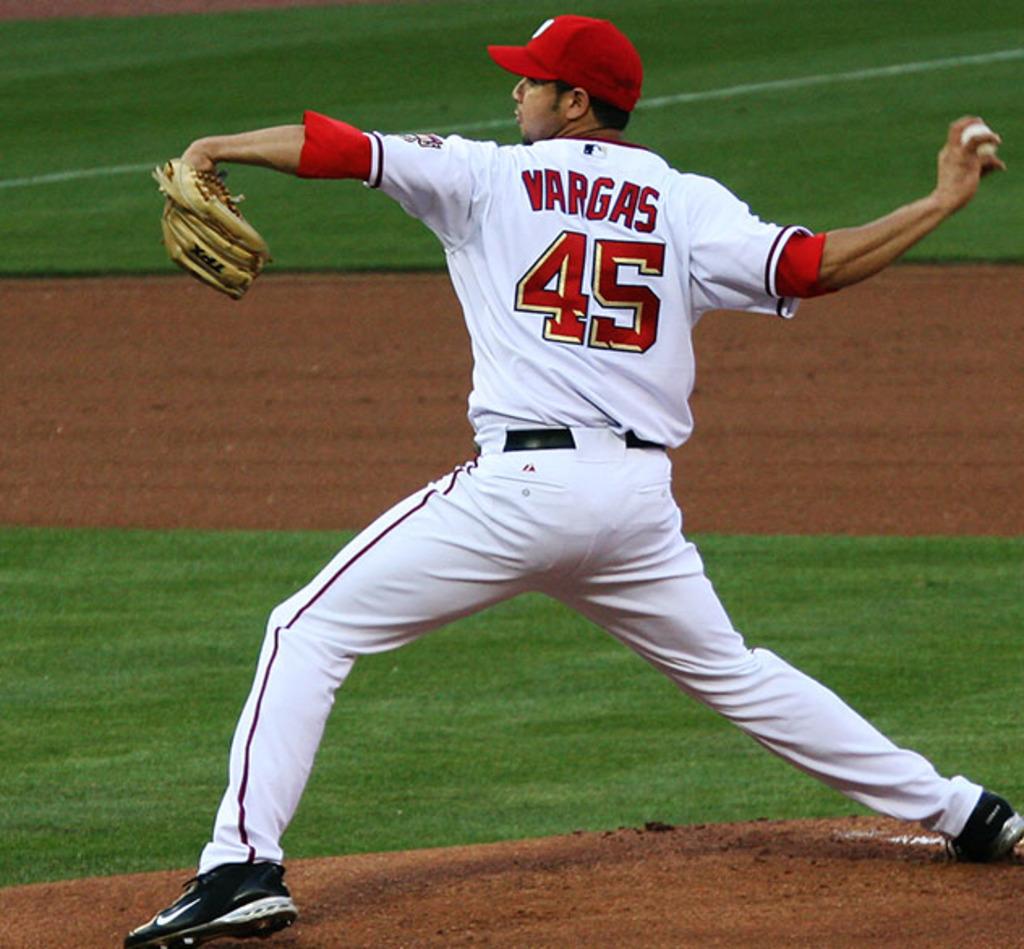What number is vargas?
Your response must be concise. 45. 